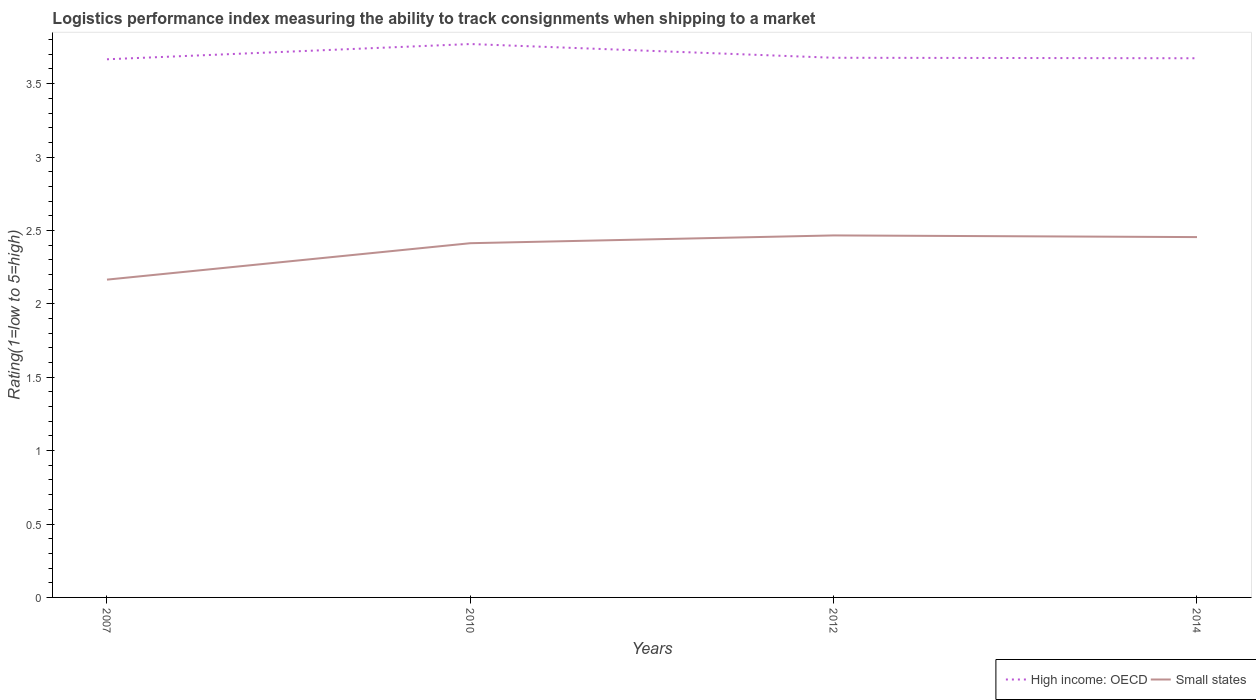Does the line corresponding to High income: OECD intersect with the line corresponding to Small states?
Ensure brevity in your answer.  No. Across all years, what is the maximum Logistic performance index in Small states?
Make the answer very short. 2.17. What is the total Logistic performance index in Small states in the graph?
Your response must be concise. 0.01. What is the difference between the highest and the second highest Logistic performance index in Small states?
Make the answer very short. 0.3. How many lines are there?
Offer a very short reply. 2. How many years are there in the graph?
Provide a succinct answer. 4. What is the difference between two consecutive major ticks on the Y-axis?
Keep it short and to the point. 0.5. Does the graph contain any zero values?
Keep it short and to the point. No. Does the graph contain grids?
Provide a succinct answer. No. Where does the legend appear in the graph?
Offer a terse response. Bottom right. How many legend labels are there?
Your response must be concise. 2. How are the legend labels stacked?
Give a very brief answer. Horizontal. What is the title of the graph?
Make the answer very short. Logistics performance index measuring the ability to track consignments when shipping to a market. What is the label or title of the X-axis?
Your response must be concise. Years. What is the label or title of the Y-axis?
Your response must be concise. Rating(1=low to 5=high). What is the Rating(1=low to 5=high) of High income: OECD in 2007?
Make the answer very short. 3.67. What is the Rating(1=low to 5=high) of Small states in 2007?
Your response must be concise. 2.17. What is the Rating(1=low to 5=high) in High income: OECD in 2010?
Make the answer very short. 3.77. What is the Rating(1=low to 5=high) in Small states in 2010?
Your answer should be very brief. 2.41. What is the Rating(1=low to 5=high) of High income: OECD in 2012?
Make the answer very short. 3.68. What is the Rating(1=low to 5=high) of Small states in 2012?
Your answer should be very brief. 2.47. What is the Rating(1=low to 5=high) of High income: OECD in 2014?
Make the answer very short. 3.67. What is the Rating(1=low to 5=high) of Small states in 2014?
Provide a succinct answer. 2.45. Across all years, what is the maximum Rating(1=low to 5=high) in High income: OECD?
Provide a succinct answer. 3.77. Across all years, what is the maximum Rating(1=low to 5=high) in Small states?
Your answer should be compact. 2.47. Across all years, what is the minimum Rating(1=low to 5=high) in High income: OECD?
Provide a short and direct response. 3.67. Across all years, what is the minimum Rating(1=low to 5=high) of Small states?
Offer a terse response. 2.17. What is the total Rating(1=low to 5=high) of High income: OECD in the graph?
Offer a very short reply. 14.79. What is the total Rating(1=low to 5=high) of Small states in the graph?
Your response must be concise. 9.5. What is the difference between the Rating(1=low to 5=high) of High income: OECD in 2007 and that in 2010?
Your answer should be very brief. -0.1. What is the difference between the Rating(1=low to 5=high) in Small states in 2007 and that in 2010?
Offer a terse response. -0.25. What is the difference between the Rating(1=low to 5=high) of High income: OECD in 2007 and that in 2012?
Make the answer very short. -0.01. What is the difference between the Rating(1=low to 5=high) of Small states in 2007 and that in 2012?
Give a very brief answer. -0.3. What is the difference between the Rating(1=low to 5=high) of High income: OECD in 2007 and that in 2014?
Give a very brief answer. -0.01. What is the difference between the Rating(1=low to 5=high) of Small states in 2007 and that in 2014?
Your answer should be very brief. -0.29. What is the difference between the Rating(1=low to 5=high) in High income: OECD in 2010 and that in 2012?
Your response must be concise. 0.09. What is the difference between the Rating(1=low to 5=high) of Small states in 2010 and that in 2012?
Offer a very short reply. -0.05. What is the difference between the Rating(1=low to 5=high) in High income: OECD in 2010 and that in 2014?
Your answer should be compact. 0.1. What is the difference between the Rating(1=low to 5=high) of Small states in 2010 and that in 2014?
Your answer should be very brief. -0.04. What is the difference between the Rating(1=low to 5=high) of High income: OECD in 2012 and that in 2014?
Make the answer very short. 0. What is the difference between the Rating(1=low to 5=high) in Small states in 2012 and that in 2014?
Provide a short and direct response. 0.01. What is the difference between the Rating(1=low to 5=high) of High income: OECD in 2007 and the Rating(1=low to 5=high) of Small states in 2010?
Your answer should be very brief. 1.25. What is the difference between the Rating(1=low to 5=high) of High income: OECD in 2007 and the Rating(1=low to 5=high) of Small states in 2014?
Offer a very short reply. 1.21. What is the difference between the Rating(1=low to 5=high) in High income: OECD in 2010 and the Rating(1=low to 5=high) in Small states in 2012?
Ensure brevity in your answer.  1.3. What is the difference between the Rating(1=low to 5=high) in High income: OECD in 2010 and the Rating(1=low to 5=high) in Small states in 2014?
Ensure brevity in your answer.  1.32. What is the difference between the Rating(1=low to 5=high) of High income: OECD in 2012 and the Rating(1=low to 5=high) of Small states in 2014?
Keep it short and to the point. 1.22. What is the average Rating(1=low to 5=high) of High income: OECD per year?
Your answer should be very brief. 3.7. What is the average Rating(1=low to 5=high) of Small states per year?
Offer a terse response. 2.37. In the year 2007, what is the difference between the Rating(1=low to 5=high) of High income: OECD and Rating(1=low to 5=high) of Small states?
Offer a very short reply. 1.5. In the year 2010, what is the difference between the Rating(1=low to 5=high) in High income: OECD and Rating(1=low to 5=high) in Small states?
Make the answer very short. 1.36. In the year 2012, what is the difference between the Rating(1=low to 5=high) of High income: OECD and Rating(1=low to 5=high) of Small states?
Keep it short and to the point. 1.21. In the year 2014, what is the difference between the Rating(1=low to 5=high) in High income: OECD and Rating(1=low to 5=high) in Small states?
Offer a very short reply. 1.22. What is the ratio of the Rating(1=low to 5=high) of High income: OECD in 2007 to that in 2010?
Provide a short and direct response. 0.97. What is the ratio of the Rating(1=low to 5=high) in Small states in 2007 to that in 2010?
Your response must be concise. 0.9. What is the ratio of the Rating(1=low to 5=high) of Small states in 2007 to that in 2012?
Offer a terse response. 0.88. What is the ratio of the Rating(1=low to 5=high) in High income: OECD in 2007 to that in 2014?
Make the answer very short. 1. What is the ratio of the Rating(1=low to 5=high) in Small states in 2007 to that in 2014?
Your response must be concise. 0.88. What is the ratio of the Rating(1=low to 5=high) in High income: OECD in 2010 to that in 2012?
Offer a terse response. 1.03. What is the ratio of the Rating(1=low to 5=high) in Small states in 2010 to that in 2012?
Give a very brief answer. 0.98. What is the ratio of the Rating(1=low to 5=high) in High income: OECD in 2010 to that in 2014?
Ensure brevity in your answer.  1.03. What is the ratio of the Rating(1=low to 5=high) of Small states in 2010 to that in 2014?
Provide a short and direct response. 0.98. What is the ratio of the Rating(1=low to 5=high) in High income: OECD in 2012 to that in 2014?
Offer a very short reply. 1. What is the ratio of the Rating(1=low to 5=high) of Small states in 2012 to that in 2014?
Your response must be concise. 1. What is the difference between the highest and the second highest Rating(1=low to 5=high) in High income: OECD?
Your answer should be compact. 0.09. What is the difference between the highest and the second highest Rating(1=low to 5=high) in Small states?
Provide a succinct answer. 0.01. What is the difference between the highest and the lowest Rating(1=low to 5=high) of High income: OECD?
Offer a very short reply. 0.1. What is the difference between the highest and the lowest Rating(1=low to 5=high) of Small states?
Provide a short and direct response. 0.3. 